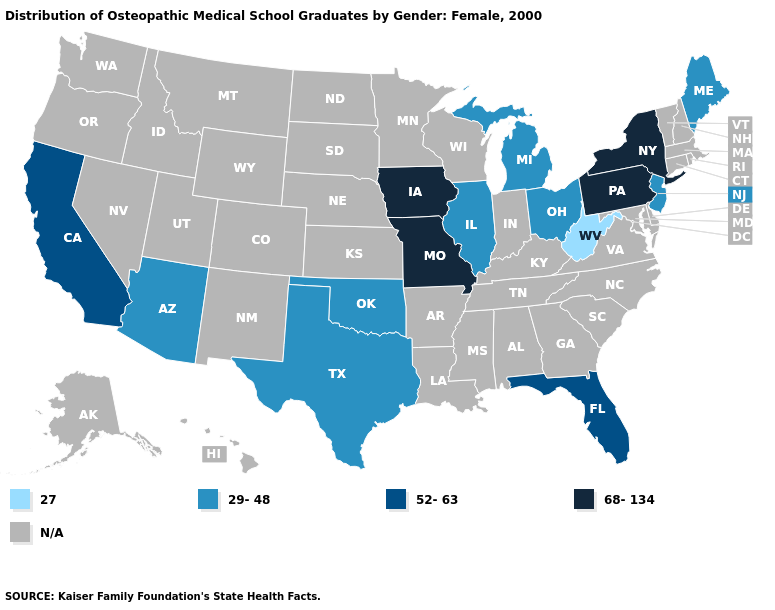Name the states that have a value in the range 29-48?
Answer briefly. Arizona, Illinois, Maine, Michigan, New Jersey, Ohio, Oklahoma, Texas. Name the states that have a value in the range 27?
Be succinct. West Virginia. What is the value of Texas?
Concise answer only. 29-48. Does Oklahoma have the highest value in the South?
Short answer required. No. What is the value of Tennessee?
Quick response, please. N/A. Among the states that border Oklahoma , which have the highest value?
Keep it brief. Missouri. Which states have the lowest value in the Northeast?
Answer briefly. Maine, New Jersey. Does Iowa have the lowest value in the MidWest?
Short answer required. No. What is the value of South Carolina?
Write a very short answer. N/A. What is the highest value in the MidWest ?
Give a very brief answer. 68-134. Among the states that border Kentucky , does West Virginia have the highest value?
Quick response, please. No. Does the first symbol in the legend represent the smallest category?
Keep it brief. Yes. What is the highest value in states that border Tennessee?
Be succinct. 68-134. 